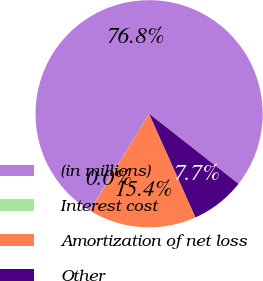Convert chart to OTSL. <chart><loc_0><loc_0><loc_500><loc_500><pie_chart><fcel>(in millions)<fcel>Interest cost<fcel>Amortization of net loss<fcel>Other<nl><fcel>76.84%<fcel>0.04%<fcel>15.4%<fcel>7.72%<nl></chart> 